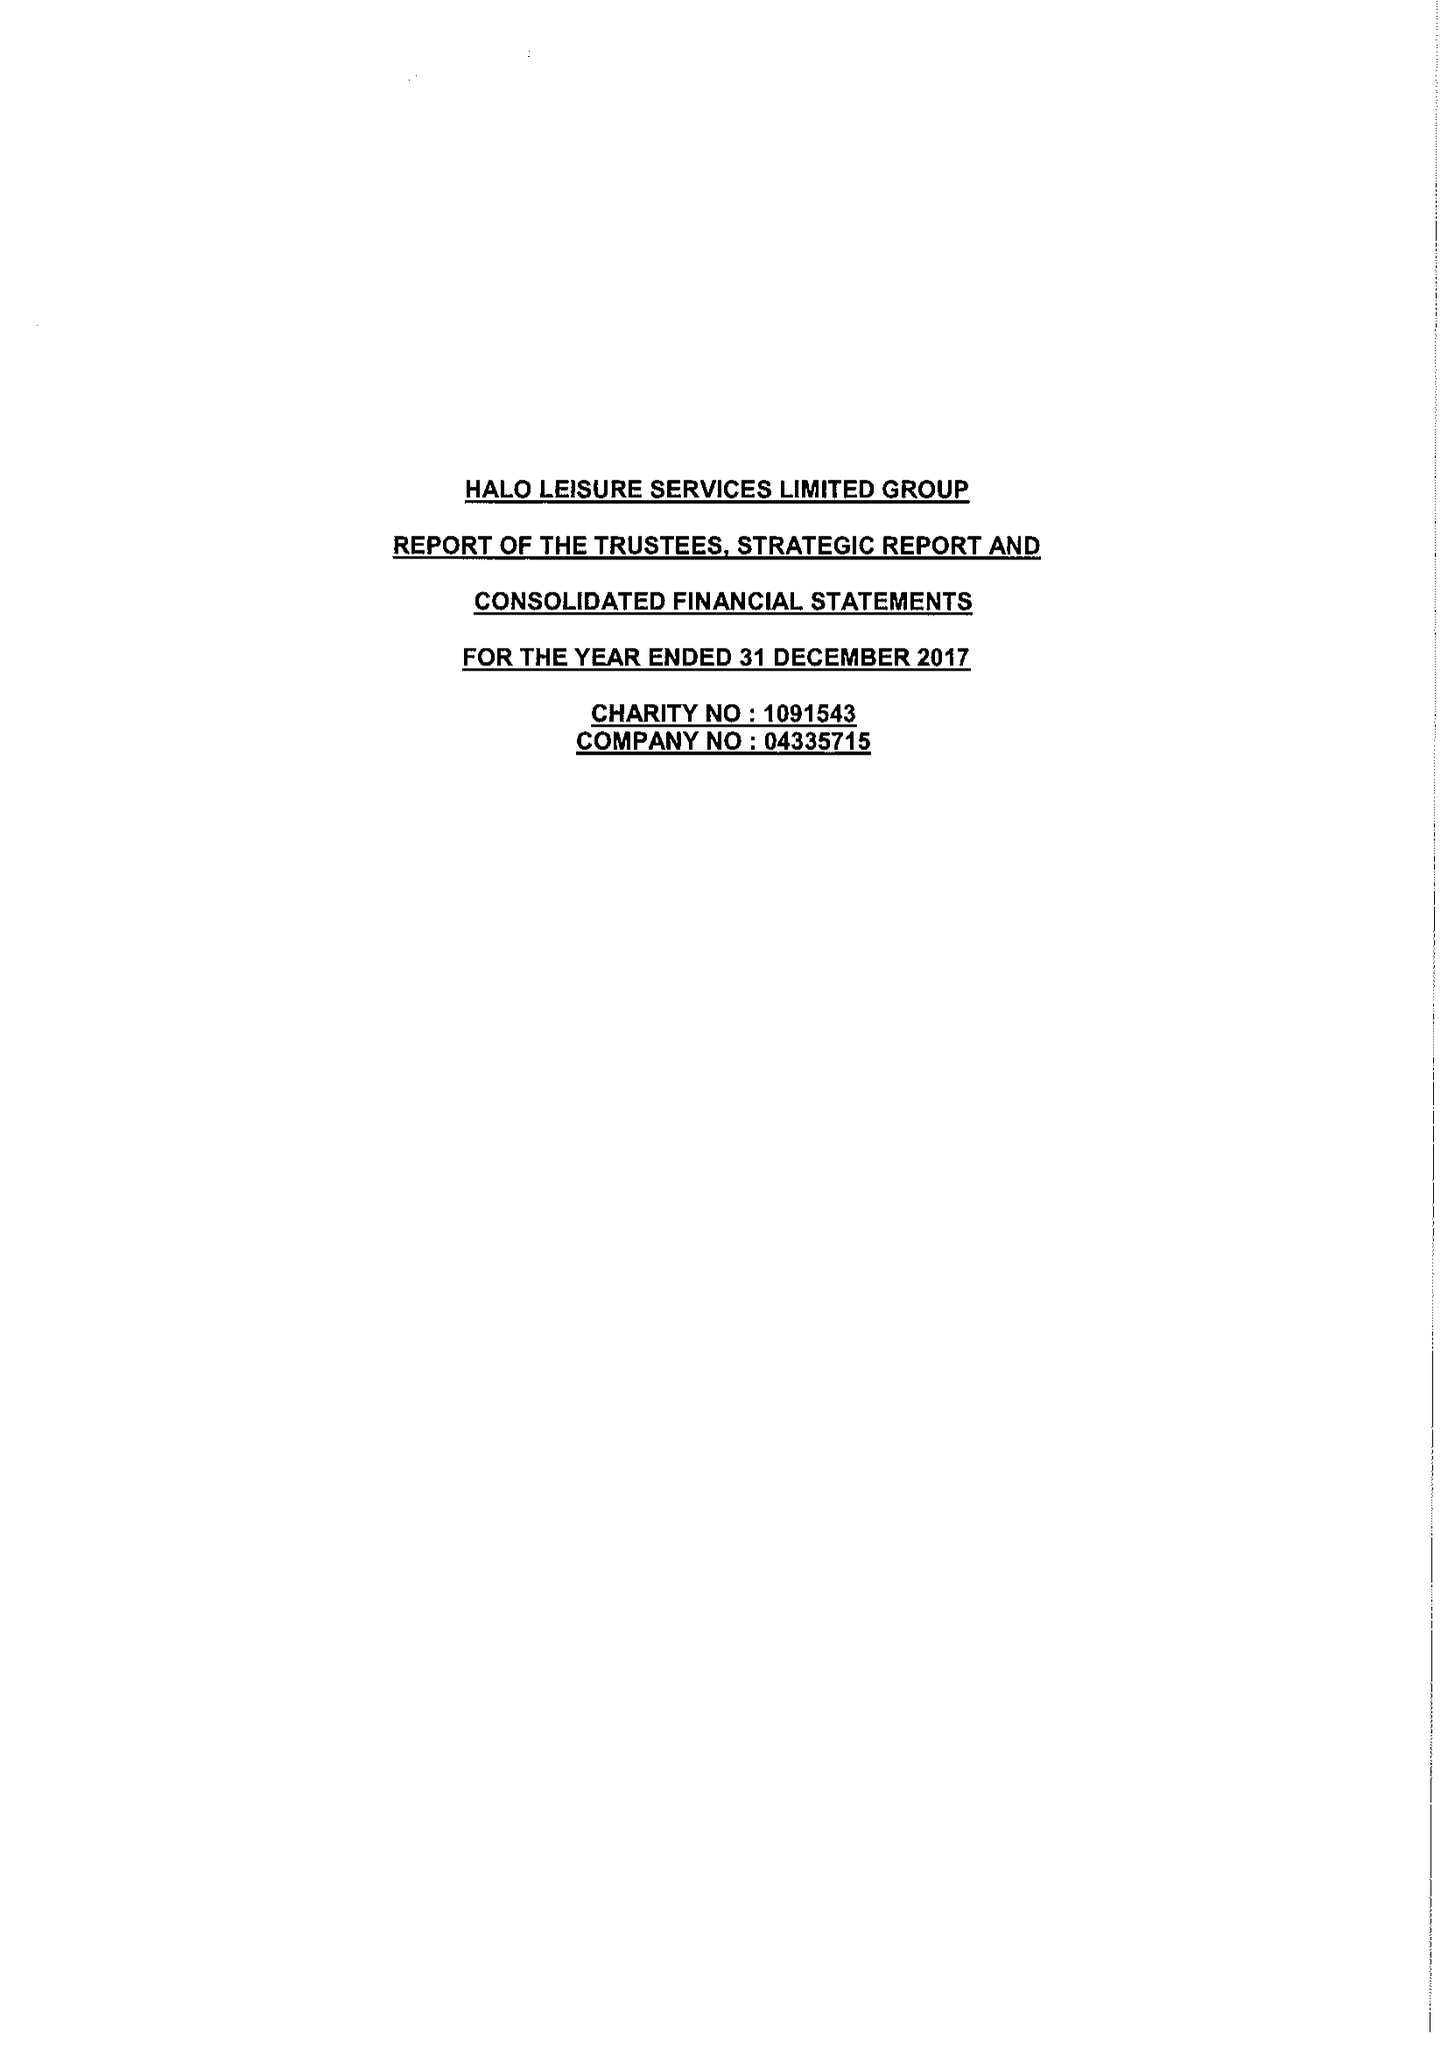What is the value for the address__street_line?
Answer the question using a single word or phrase. BROAD STREET 